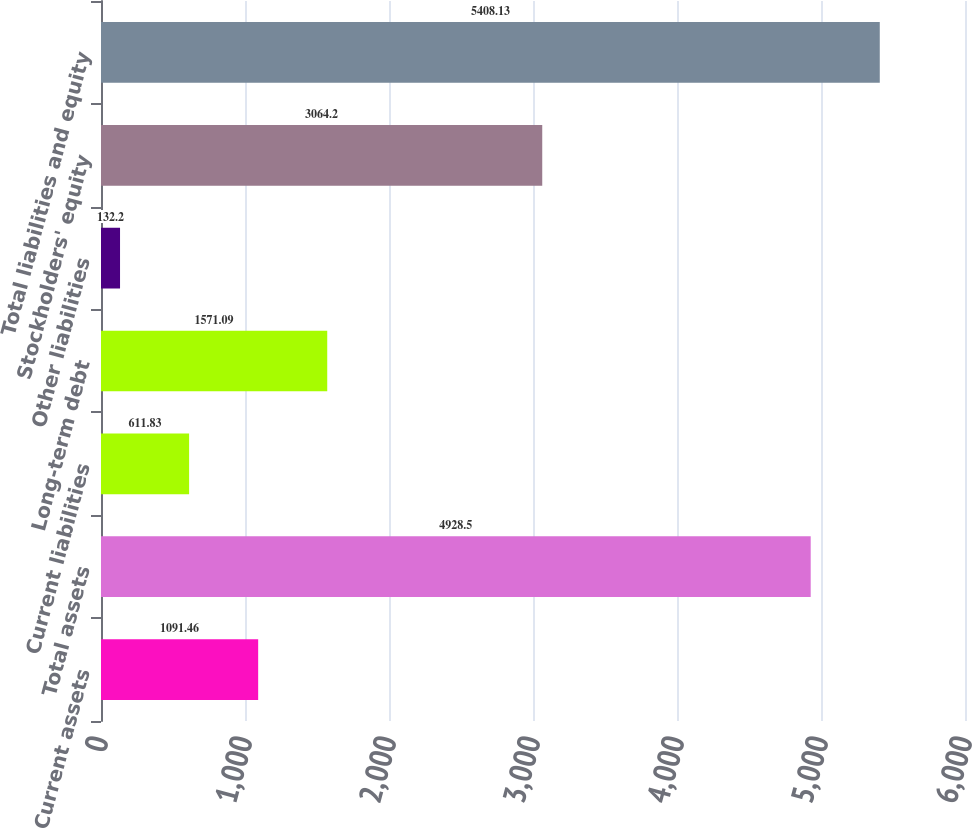Convert chart to OTSL. <chart><loc_0><loc_0><loc_500><loc_500><bar_chart><fcel>Current assets<fcel>Total assets<fcel>Current liabilities<fcel>Long-term debt<fcel>Other liabilities<fcel>Stockholders' equity<fcel>Total liabilities and equity<nl><fcel>1091.46<fcel>4928.5<fcel>611.83<fcel>1571.09<fcel>132.2<fcel>3064.2<fcel>5408.13<nl></chart> 